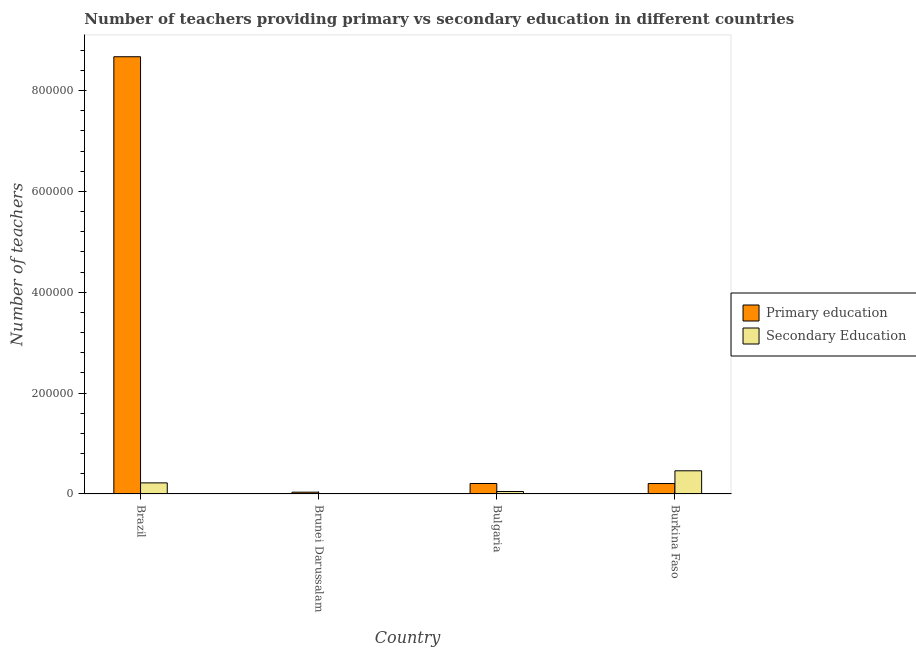How many different coloured bars are there?
Your answer should be compact. 2. What is the label of the 2nd group of bars from the left?
Keep it short and to the point. Brunei Darussalam. In how many cases, is the number of bars for a given country not equal to the number of legend labels?
Make the answer very short. 0. What is the number of secondary teachers in Burkina Faso?
Ensure brevity in your answer.  4.60e+04. Across all countries, what is the maximum number of secondary teachers?
Keep it short and to the point. 4.60e+04. Across all countries, what is the minimum number of secondary teachers?
Provide a succinct answer. 231. In which country was the number of primary teachers maximum?
Your answer should be very brief. Brazil. In which country was the number of primary teachers minimum?
Provide a succinct answer. Brunei Darussalam. What is the total number of secondary teachers in the graph?
Make the answer very short. 7.31e+04. What is the difference between the number of secondary teachers in Brazil and that in Bulgaria?
Your answer should be very brief. 1.71e+04. What is the difference between the number of secondary teachers in Brunei Darussalam and the number of primary teachers in Bulgaria?
Provide a short and direct response. -2.06e+04. What is the average number of secondary teachers per country?
Provide a short and direct response. 1.83e+04. What is the difference between the number of primary teachers and number of secondary teachers in Brunei Darussalam?
Provide a short and direct response. 3305. In how many countries, is the number of secondary teachers greater than 840000 ?
Provide a short and direct response. 0. What is the ratio of the number of primary teachers in Brunei Darussalam to that in Burkina Faso?
Make the answer very short. 0.17. What is the difference between the highest and the second highest number of secondary teachers?
Provide a short and direct response. 2.40e+04. What is the difference between the highest and the lowest number of secondary teachers?
Provide a succinct answer. 4.58e+04. In how many countries, is the number of primary teachers greater than the average number of primary teachers taken over all countries?
Provide a succinct answer. 1. What does the 2nd bar from the left in Burkina Faso represents?
Offer a terse response. Secondary Education. What does the 1st bar from the right in Bulgaria represents?
Ensure brevity in your answer.  Secondary Education. How many bars are there?
Make the answer very short. 8. Are all the bars in the graph horizontal?
Provide a succinct answer. No. How many countries are there in the graph?
Your answer should be compact. 4. Are the values on the major ticks of Y-axis written in scientific E-notation?
Your answer should be very brief. No. How many legend labels are there?
Provide a short and direct response. 2. What is the title of the graph?
Make the answer very short. Number of teachers providing primary vs secondary education in different countries. What is the label or title of the X-axis?
Offer a very short reply. Country. What is the label or title of the Y-axis?
Provide a short and direct response. Number of teachers. What is the Number of teachers in Primary education in Brazil?
Your answer should be compact. 8.67e+05. What is the Number of teachers of Secondary Education in Brazil?
Offer a very short reply. 2.20e+04. What is the Number of teachers in Primary education in Brunei Darussalam?
Your response must be concise. 3536. What is the Number of teachers in Secondary Education in Brunei Darussalam?
Give a very brief answer. 231. What is the Number of teachers in Primary education in Bulgaria?
Provide a short and direct response. 2.08e+04. What is the Number of teachers of Secondary Education in Bulgaria?
Your response must be concise. 4883. What is the Number of teachers in Primary education in Burkina Faso?
Your response must be concise. 2.07e+04. What is the Number of teachers of Secondary Education in Burkina Faso?
Make the answer very short. 4.60e+04. Across all countries, what is the maximum Number of teachers in Primary education?
Give a very brief answer. 8.67e+05. Across all countries, what is the maximum Number of teachers in Secondary Education?
Your response must be concise. 4.60e+04. Across all countries, what is the minimum Number of teachers of Primary education?
Your answer should be very brief. 3536. Across all countries, what is the minimum Number of teachers of Secondary Education?
Provide a succinct answer. 231. What is the total Number of teachers in Primary education in the graph?
Provide a succinct answer. 9.12e+05. What is the total Number of teachers in Secondary Education in the graph?
Give a very brief answer. 7.31e+04. What is the difference between the Number of teachers of Primary education in Brazil and that in Brunei Darussalam?
Offer a very short reply. 8.63e+05. What is the difference between the Number of teachers of Secondary Education in Brazil and that in Brunei Darussalam?
Offer a terse response. 2.18e+04. What is the difference between the Number of teachers in Primary education in Brazil and that in Bulgaria?
Offer a terse response. 8.46e+05. What is the difference between the Number of teachers in Secondary Education in Brazil and that in Bulgaria?
Give a very brief answer. 1.71e+04. What is the difference between the Number of teachers in Primary education in Brazil and that in Burkina Faso?
Make the answer very short. 8.46e+05. What is the difference between the Number of teachers in Secondary Education in Brazil and that in Burkina Faso?
Make the answer very short. -2.40e+04. What is the difference between the Number of teachers in Primary education in Brunei Darussalam and that in Bulgaria?
Your answer should be very brief. -1.73e+04. What is the difference between the Number of teachers in Secondary Education in Brunei Darussalam and that in Bulgaria?
Provide a succinct answer. -4652. What is the difference between the Number of teachers in Primary education in Brunei Darussalam and that in Burkina Faso?
Give a very brief answer. -1.71e+04. What is the difference between the Number of teachers of Secondary Education in Brunei Darussalam and that in Burkina Faso?
Your response must be concise. -4.58e+04. What is the difference between the Number of teachers of Primary education in Bulgaria and that in Burkina Faso?
Your answer should be very brief. 113. What is the difference between the Number of teachers in Secondary Education in Bulgaria and that in Burkina Faso?
Give a very brief answer. -4.11e+04. What is the difference between the Number of teachers of Primary education in Brazil and the Number of teachers of Secondary Education in Brunei Darussalam?
Ensure brevity in your answer.  8.67e+05. What is the difference between the Number of teachers of Primary education in Brazil and the Number of teachers of Secondary Education in Bulgaria?
Offer a very short reply. 8.62e+05. What is the difference between the Number of teachers in Primary education in Brazil and the Number of teachers in Secondary Education in Burkina Faso?
Offer a very short reply. 8.21e+05. What is the difference between the Number of teachers of Primary education in Brunei Darussalam and the Number of teachers of Secondary Education in Bulgaria?
Your response must be concise. -1347. What is the difference between the Number of teachers in Primary education in Brunei Darussalam and the Number of teachers in Secondary Education in Burkina Faso?
Make the answer very short. -4.24e+04. What is the difference between the Number of teachers of Primary education in Bulgaria and the Number of teachers of Secondary Education in Burkina Faso?
Provide a short and direct response. -2.52e+04. What is the average Number of teachers in Primary education per country?
Provide a short and direct response. 2.28e+05. What is the average Number of teachers of Secondary Education per country?
Provide a short and direct response. 1.83e+04. What is the difference between the Number of teachers of Primary education and Number of teachers of Secondary Education in Brazil?
Offer a terse response. 8.45e+05. What is the difference between the Number of teachers of Primary education and Number of teachers of Secondary Education in Brunei Darussalam?
Your response must be concise. 3305. What is the difference between the Number of teachers in Primary education and Number of teachers in Secondary Education in Bulgaria?
Your answer should be very brief. 1.59e+04. What is the difference between the Number of teachers in Primary education and Number of teachers in Secondary Education in Burkina Faso?
Provide a succinct answer. -2.53e+04. What is the ratio of the Number of teachers of Primary education in Brazil to that in Brunei Darussalam?
Offer a terse response. 245.19. What is the ratio of the Number of teachers in Secondary Education in Brazil to that in Brunei Darussalam?
Your answer should be compact. 95.23. What is the ratio of the Number of teachers in Primary education in Brazil to that in Bulgaria?
Your response must be concise. 41.7. What is the ratio of the Number of teachers in Secondary Education in Brazil to that in Bulgaria?
Provide a succinct answer. 4.5. What is the ratio of the Number of teachers of Primary education in Brazil to that in Burkina Faso?
Your answer should be compact. 41.93. What is the ratio of the Number of teachers in Secondary Education in Brazil to that in Burkina Faso?
Ensure brevity in your answer.  0.48. What is the ratio of the Number of teachers of Primary education in Brunei Darussalam to that in Bulgaria?
Provide a short and direct response. 0.17. What is the ratio of the Number of teachers in Secondary Education in Brunei Darussalam to that in Bulgaria?
Keep it short and to the point. 0.05. What is the ratio of the Number of teachers of Primary education in Brunei Darussalam to that in Burkina Faso?
Your response must be concise. 0.17. What is the ratio of the Number of teachers of Secondary Education in Brunei Darussalam to that in Burkina Faso?
Make the answer very short. 0.01. What is the ratio of the Number of teachers of Primary education in Bulgaria to that in Burkina Faso?
Keep it short and to the point. 1.01. What is the ratio of the Number of teachers in Secondary Education in Bulgaria to that in Burkina Faso?
Give a very brief answer. 0.11. What is the difference between the highest and the second highest Number of teachers in Primary education?
Provide a succinct answer. 8.46e+05. What is the difference between the highest and the second highest Number of teachers of Secondary Education?
Ensure brevity in your answer.  2.40e+04. What is the difference between the highest and the lowest Number of teachers in Primary education?
Give a very brief answer. 8.63e+05. What is the difference between the highest and the lowest Number of teachers in Secondary Education?
Your response must be concise. 4.58e+04. 